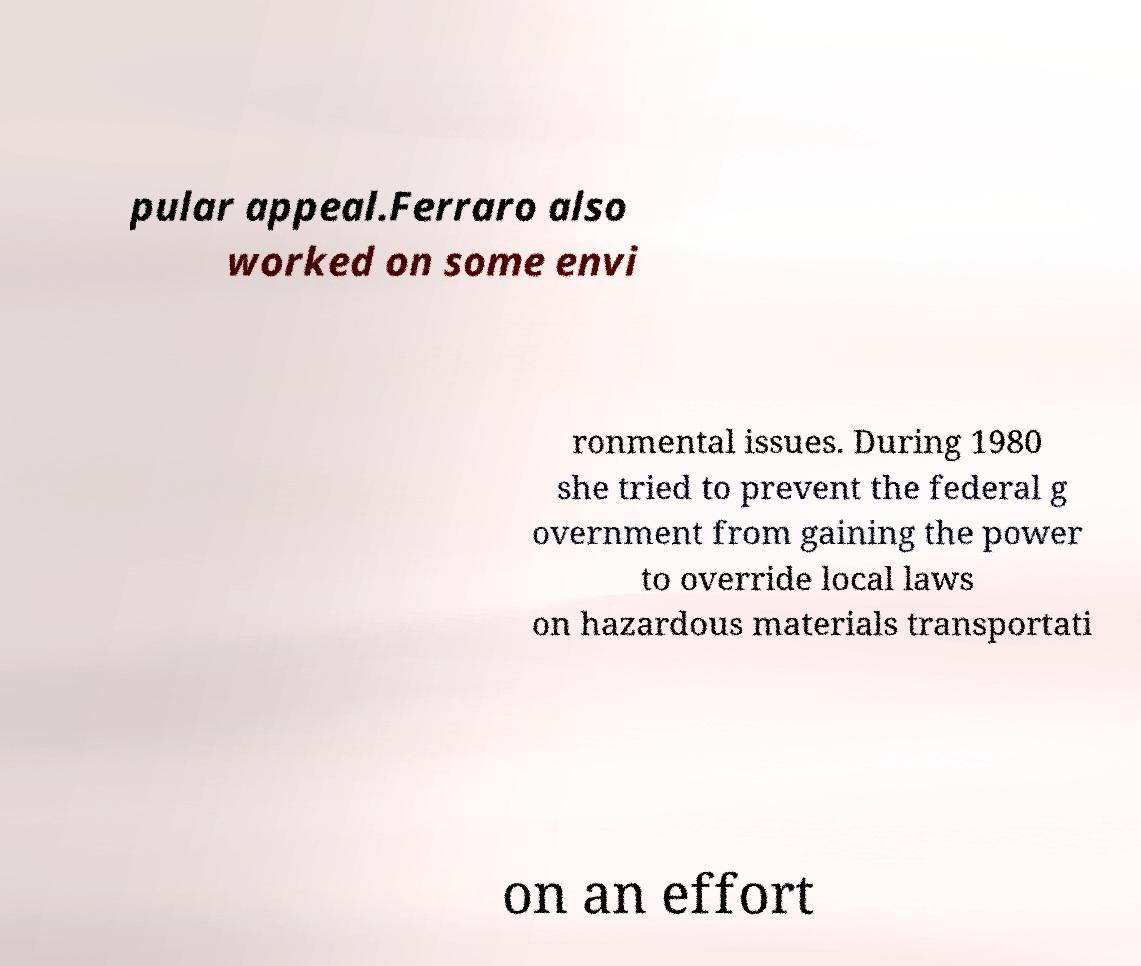Can you read and provide the text displayed in the image?This photo seems to have some interesting text. Can you extract and type it out for me? pular appeal.Ferraro also worked on some envi ronmental issues. During 1980 she tried to prevent the federal g overnment from gaining the power to override local laws on hazardous materials transportati on an effort 